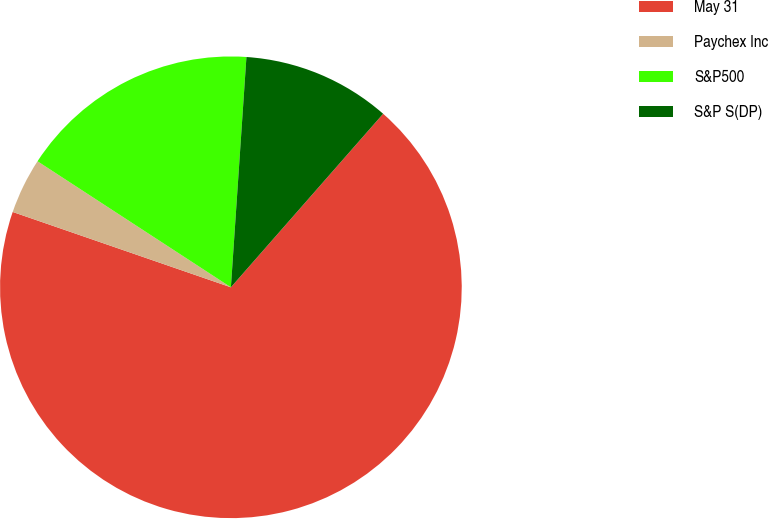Convert chart. <chart><loc_0><loc_0><loc_500><loc_500><pie_chart><fcel>May 31<fcel>Paychex Inc<fcel>S&P500<fcel>S&P S(DP)<nl><fcel>68.83%<fcel>3.9%<fcel>16.88%<fcel>10.39%<nl></chart> 